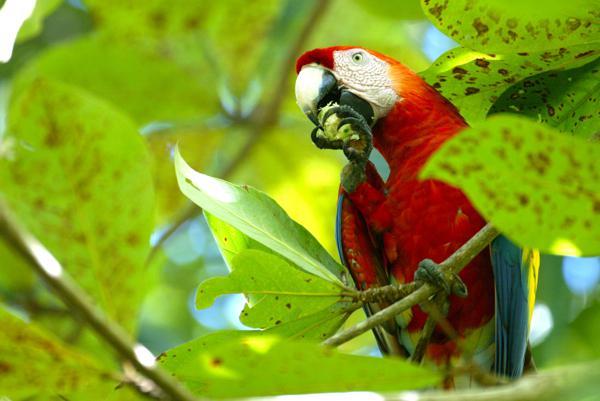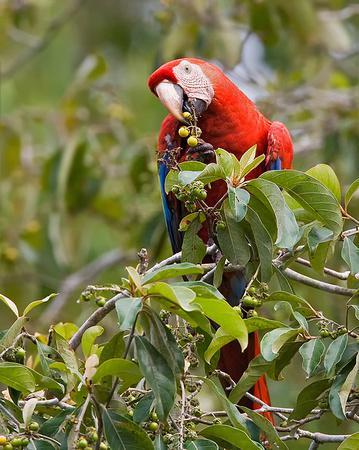The first image is the image on the left, the second image is the image on the right. Considering the images on both sides, is "Each image shows a single parrot surrounded by leafy green foliage, and all parrots have heads angled leftward." valid? Answer yes or no. Yes. The first image is the image on the left, the second image is the image on the right. Examine the images to the left and right. Is the description "One macaw is not eating anything." accurate? Answer yes or no. No. 